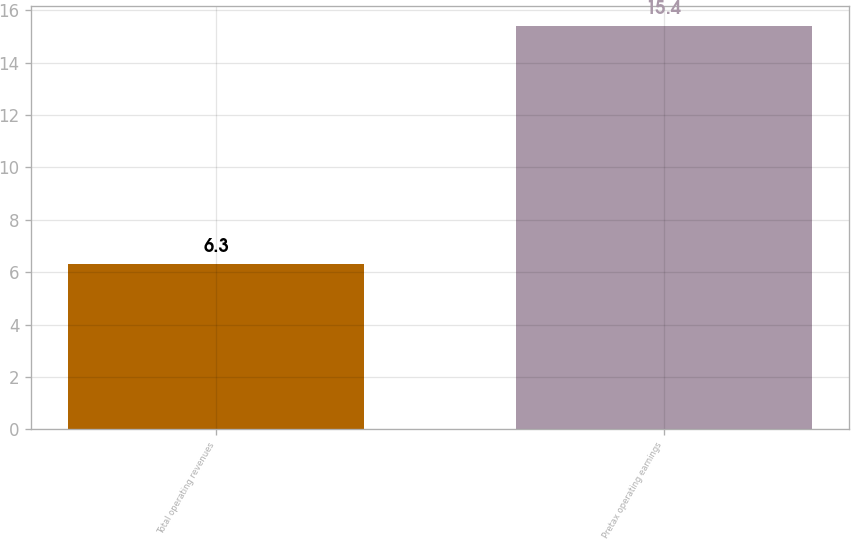<chart> <loc_0><loc_0><loc_500><loc_500><bar_chart><fcel>Total operating revenues<fcel>Pretax operating earnings<nl><fcel>6.3<fcel>15.4<nl></chart> 